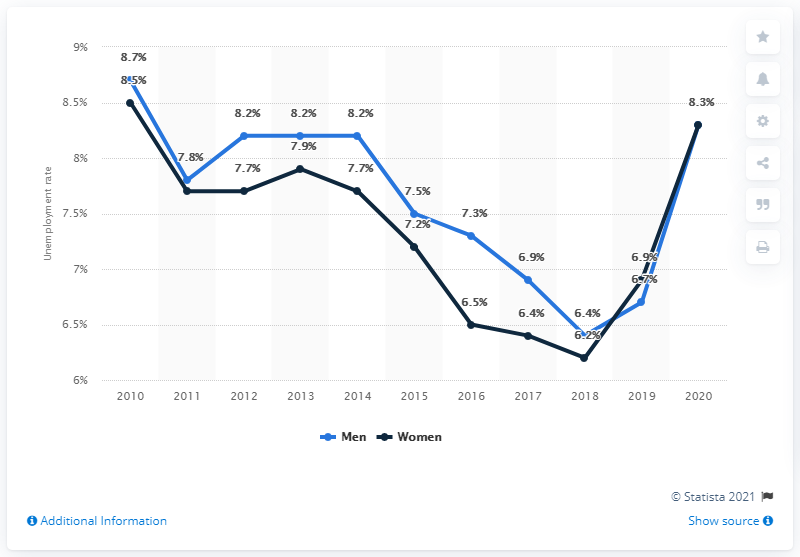Specify some key components in this picture. In 2020, the unemployment rate for both men and women in Sweden was 8.3%. In 2020, the unemployment rate in Sweden was 6.7%. 